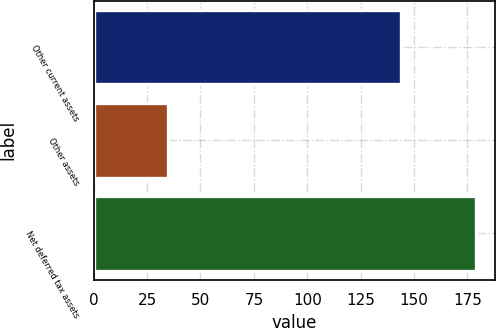Convert chart to OTSL. <chart><loc_0><loc_0><loc_500><loc_500><bar_chart><fcel>Other current assets<fcel>Other assets<fcel>Net deferred tax assets<nl><fcel>144<fcel>35<fcel>179<nl></chart> 